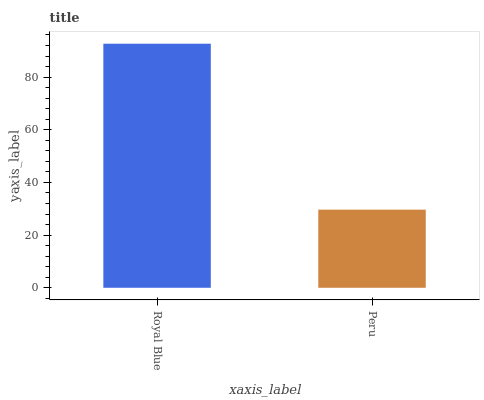Is Peru the minimum?
Answer yes or no. Yes. Is Royal Blue the maximum?
Answer yes or no. Yes. Is Peru the maximum?
Answer yes or no. No. Is Royal Blue greater than Peru?
Answer yes or no. Yes. Is Peru less than Royal Blue?
Answer yes or no. Yes. Is Peru greater than Royal Blue?
Answer yes or no. No. Is Royal Blue less than Peru?
Answer yes or no. No. Is Royal Blue the high median?
Answer yes or no. Yes. Is Peru the low median?
Answer yes or no. Yes. Is Peru the high median?
Answer yes or no. No. Is Royal Blue the low median?
Answer yes or no. No. 